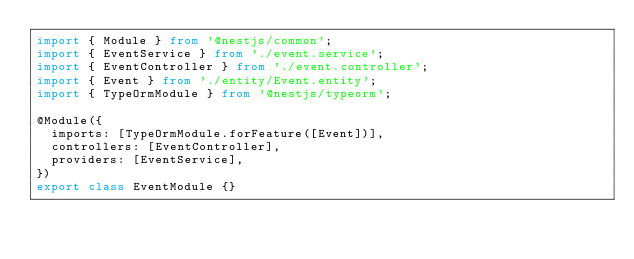Convert code to text. <code><loc_0><loc_0><loc_500><loc_500><_TypeScript_>import { Module } from '@nestjs/common';
import { EventService } from './event.service';
import { EventController } from './event.controller';
import { Event } from './entity/Event.entity';
import { TypeOrmModule } from '@nestjs/typeorm';

@Module({
  imports: [TypeOrmModule.forFeature([Event])],
  controllers: [EventController],
  providers: [EventService],
})
export class EventModule {}
</code> 